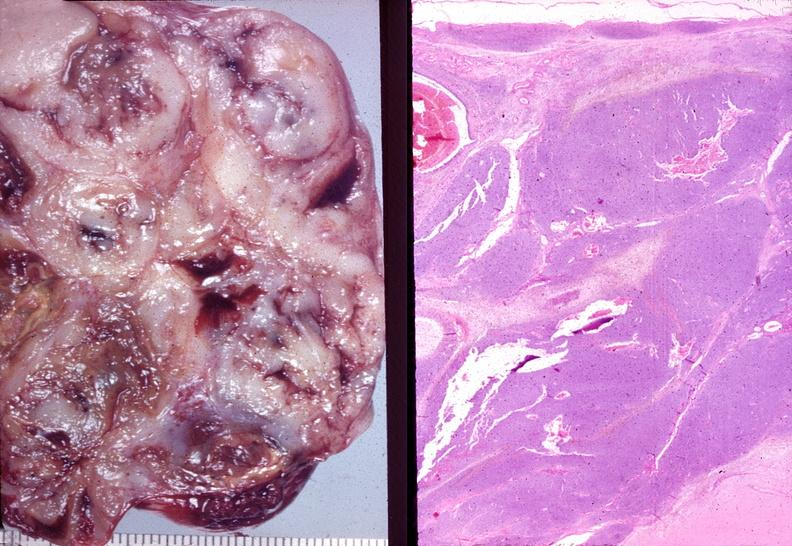does yo show ovary, granulosa cell tumor?
Answer the question using a single word or phrase. No 